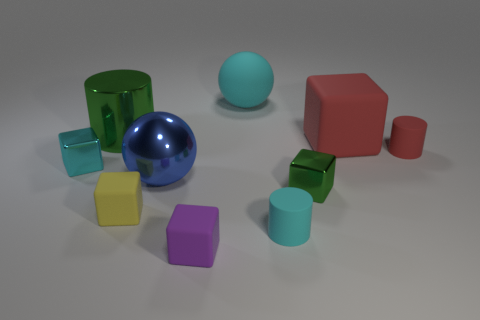Are there more blocks that are behind the green block than big green spheres?
Provide a short and direct response. Yes. Are there any large gray cylinders?
Your response must be concise. No. What number of large things are either brown cylinders or cyan spheres?
Ensure brevity in your answer.  1. Is there anything else of the same color as the big shiny cylinder?
Provide a short and direct response. Yes. There is a tiny cyan object that is made of the same material as the big cyan thing; what shape is it?
Provide a short and direct response. Cylinder. What size is the cyan rubber thing that is behind the tiny green metal thing?
Keep it short and to the point. Large. The tiny cyan metal thing is what shape?
Make the answer very short. Cube. There is a metallic cube to the left of the large matte ball; is it the same size as the cylinder on the left side of the purple cube?
Your response must be concise. No. There is a metal block that is left of the thing that is behind the green metal thing left of the yellow block; how big is it?
Provide a short and direct response. Small. There is a metal object that is right of the small cylinder in front of the red rubber object that is in front of the red block; what shape is it?
Keep it short and to the point. Cube. 